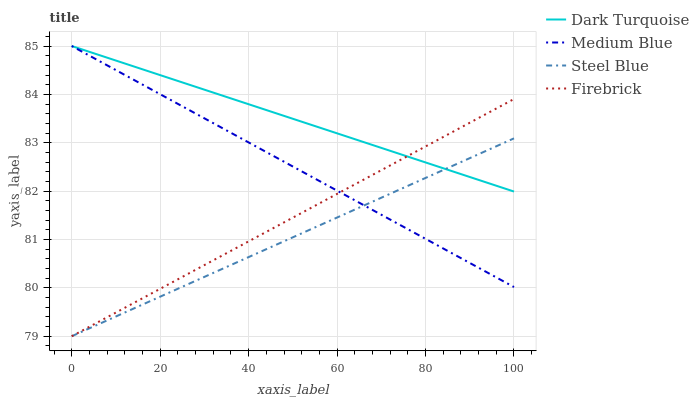Does Steel Blue have the minimum area under the curve?
Answer yes or no. Yes. Does Dark Turquoise have the maximum area under the curve?
Answer yes or no. Yes. Does Firebrick have the minimum area under the curve?
Answer yes or no. No. Does Firebrick have the maximum area under the curve?
Answer yes or no. No. Is Dark Turquoise the smoothest?
Answer yes or no. Yes. Is Firebrick the roughest?
Answer yes or no. Yes. Is Medium Blue the smoothest?
Answer yes or no. No. Is Medium Blue the roughest?
Answer yes or no. No. Does Firebrick have the lowest value?
Answer yes or no. Yes. Does Medium Blue have the lowest value?
Answer yes or no. No. Does Medium Blue have the highest value?
Answer yes or no. Yes. Does Firebrick have the highest value?
Answer yes or no. No. Does Firebrick intersect Steel Blue?
Answer yes or no. Yes. Is Firebrick less than Steel Blue?
Answer yes or no. No. Is Firebrick greater than Steel Blue?
Answer yes or no. No. 